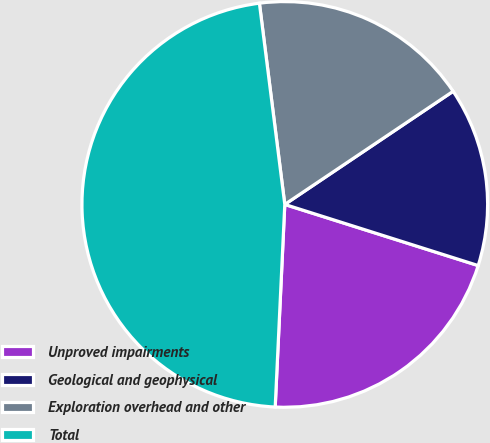Convert chart to OTSL. <chart><loc_0><loc_0><loc_500><loc_500><pie_chart><fcel>Unproved impairments<fcel>Geological and geophysical<fcel>Exploration overhead and other<fcel>Total<nl><fcel>20.88%<fcel>14.29%<fcel>17.58%<fcel>47.25%<nl></chart> 